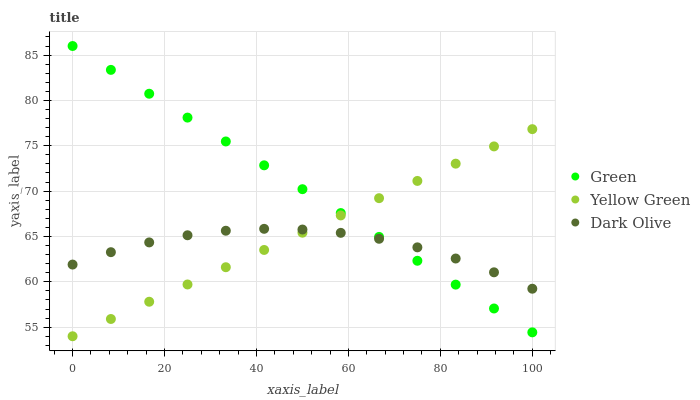Does Dark Olive have the minimum area under the curve?
Answer yes or no. Yes. Does Green have the maximum area under the curve?
Answer yes or no. Yes. Does Yellow Green have the minimum area under the curve?
Answer yes or no. No. Does Yellow Green have the maximum area under the curve?
Answer yes or no. No. Is Yellow Green the smoothest?
Answer yes or no. Yes. Is Dark Olive the roughest?
Answer yes or no. Yes. Is Green the smoothest?
Answer yes or no. No. Is Green the roughest?
Answer yes or no. No. Does Yellow Green have the lowest value?
Answer yes or no. Yes. Does Green have the lowest value?
Answer yes or no. No. Does Green have the highest value?
Answer yes or no. Yes. Does Yellow Green have the highest value?
Answer yes or no. No. Does Green intersect Dark Olive?
Answer yes or no. Yes. Is Green less than Dark Olive?
Answer yes or no. No. Is Green greater than Dark Olive?
Answer yes or no. No. 